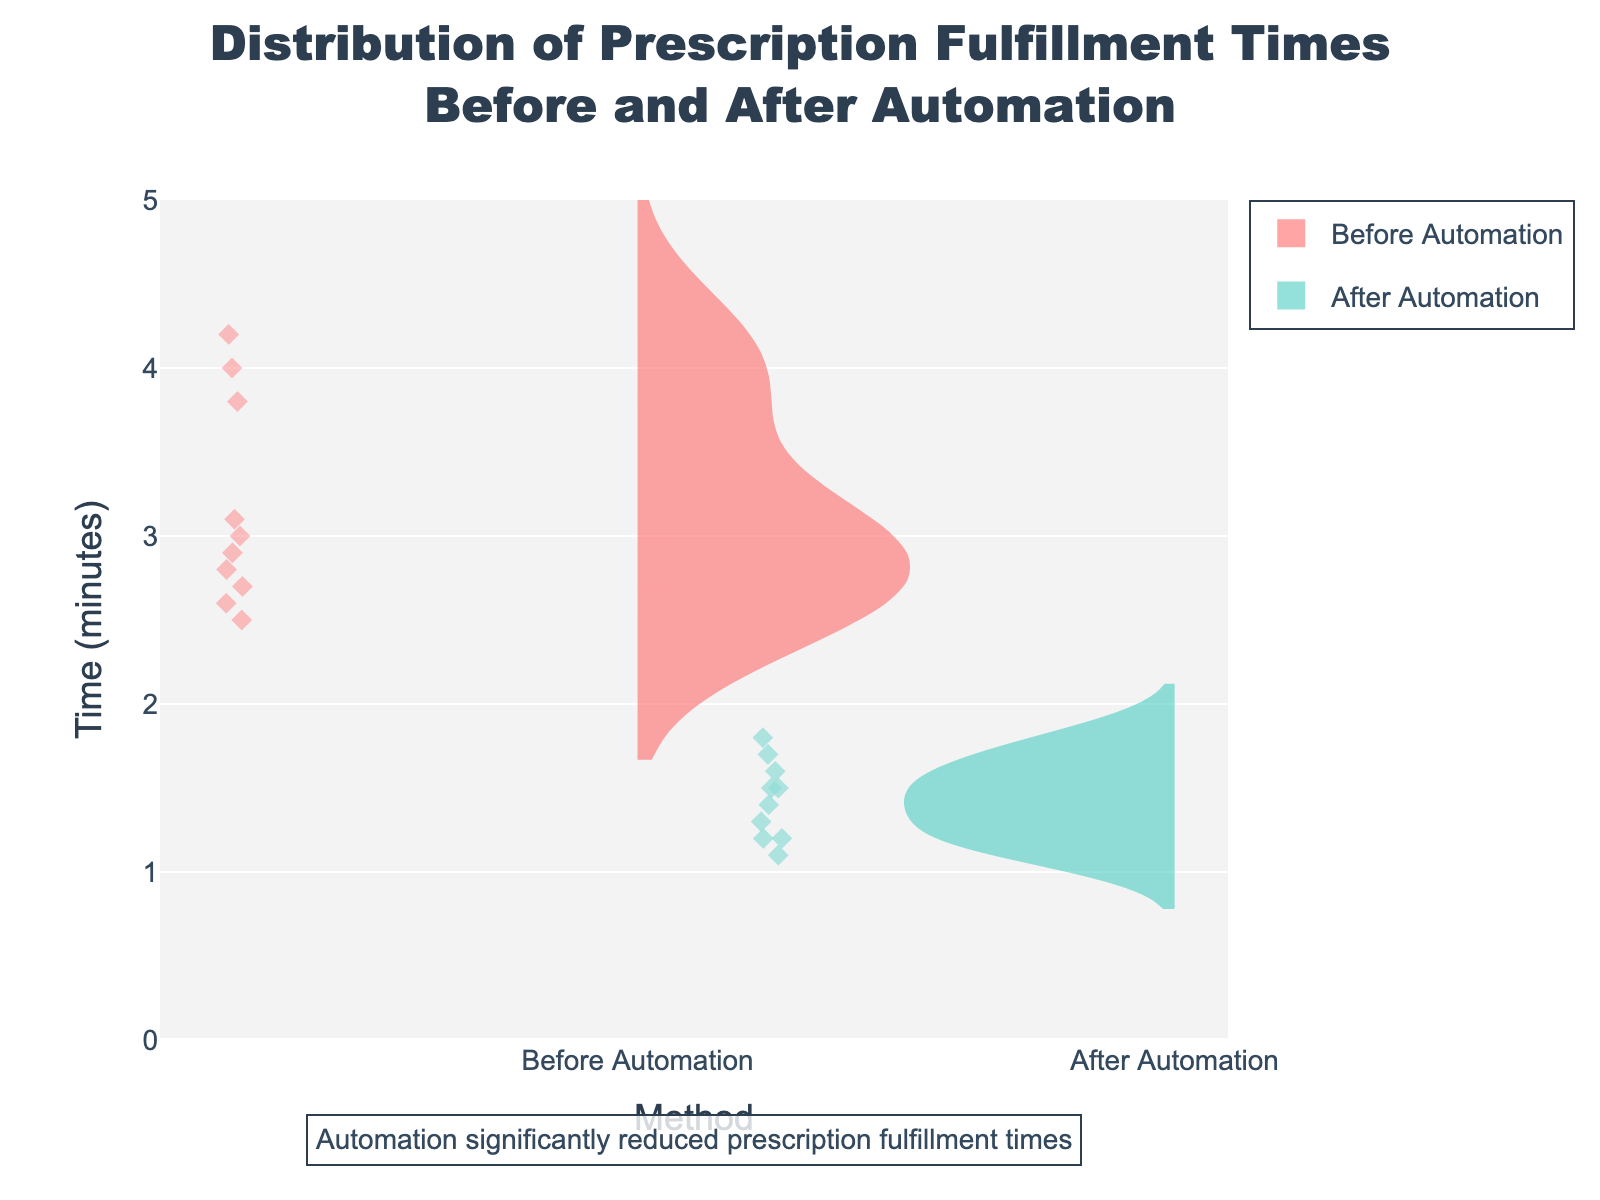What's the title of the figure? The title is displayed at the top of the figure in a larger font size, specifying the main subject of the visualized data.
Answer: Distribution of Prescription Fulfillment Times Before and After Automation What do the two colors represent in the plot? Each color represents a different method of prescription fulfillment; we can identify what they stand for from the legend in the plot. The red color represents "Before Automation" and the teal color represents "After Automation".
Answer: Red represents "Before Automation" and teal represents "After Automation" Which method shows a wider distribution of fulfillment times? By looking at the spread and width of each violin plot, we can see that "Before Automation" (represented by the red color) shows a wider spread of values than "After Automation".
Answer: Before Automation What is the range of prescription fulfillment times for "Before Automation"? By observing the extent of the red violin plot along the y-axis, we can see it ranges from approximately 2.5 minutes to 4.2 minutes.
Answer: 2.5 to 4.2 minutes What is the median fulfillment time for "After Automation"? Each violin plot has a horizontal line that represents the median, and by looking at the teal violin plot, we can see this line is around 1.4 minutes on the y-axis.
Answer: 1.4 minutes Which method shows a lower mean fulfillment time? The mean is indicated by a line within the box of each violin plot. By observing the position of these lines, the mean for "After Automation" is lower than that for "Before Automation".
Answer: After Automation What is the mean fulfillment time before automation? The mean time before automation can be identified from the meanline within the red violin plot. It is at around 3.2 minutes from the y-axis.
Answer: 3.2 minutes How much did automation reduce the mean fulfillment time? To find the reduction, we subtract the mean after automation (around 1.4 minutes) from the mean before automation (around 3.2 minutes). Therefore, the reduction is about 3.2 - 1.4.
Answer: 1.8 minutes Which method has a data point at approximately 4 minutes? By observing the individual points within the violin plots, we can identify that the red violin plot for "Before Automation" has a data point around 4 minutes.
Answer: Before Automation How did the overall trend in fulfillment times change after automation? The "Before Automation" data shows a wider and higher range of fulfillment times, whereas the "After Automation" data shows a narrower and lower range. This indicates that automation reduced both the average time and the variability of fulfillment times.
Answer: Reduced average time and variability 